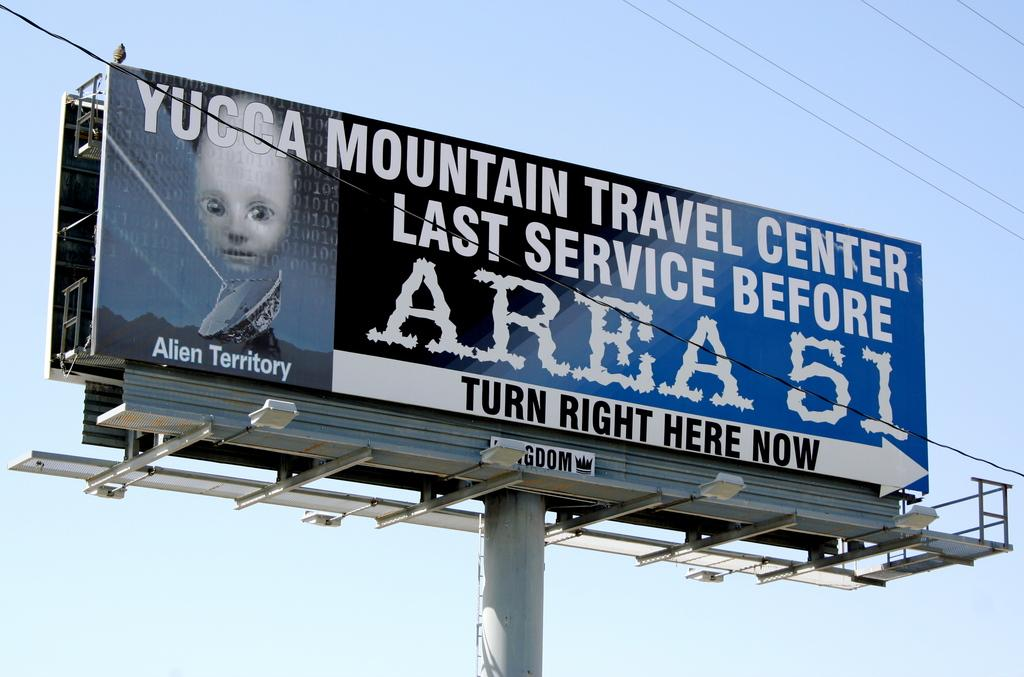<image>
Provide a brief description of the given image. Blue billboard that says Alien Territory under a face of an alien. 